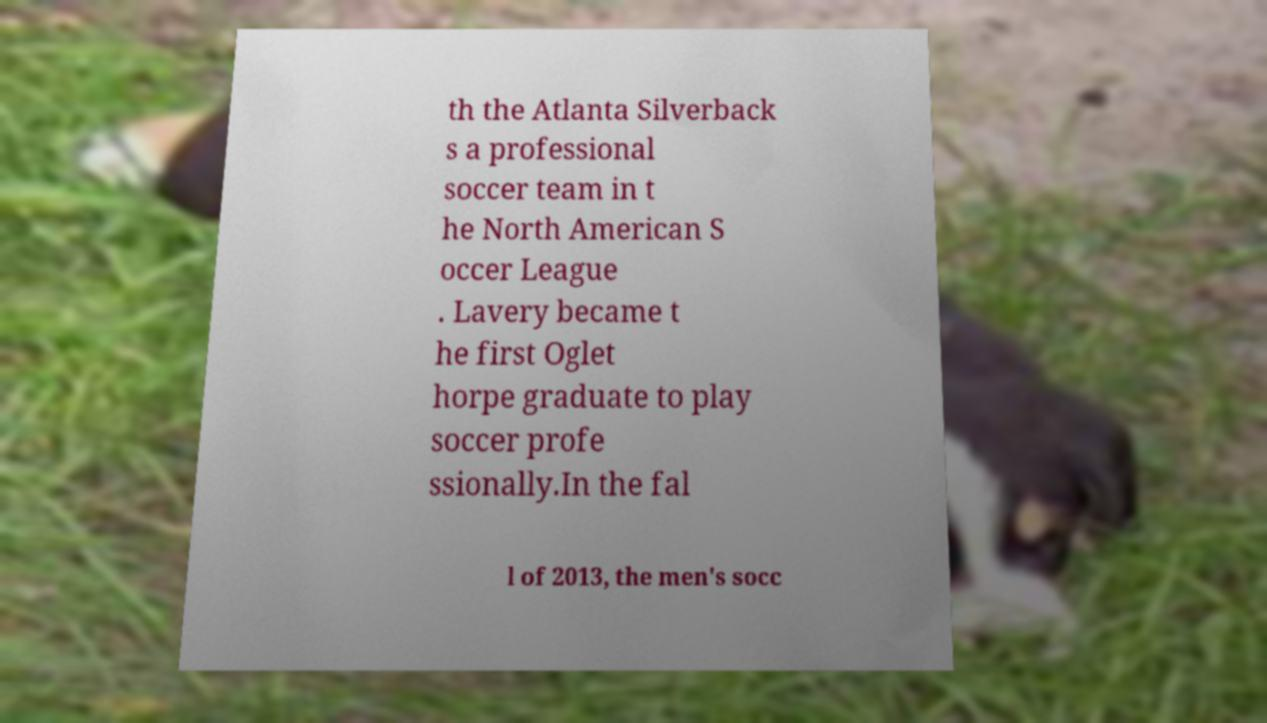Could you extract and type out the text from this image? th the Atlanta Silverback s a professional soccer team in t he North American S occer League . Lavery became t he first Oglet horpe graduate to play soccer profe ssionally.In the fal l of 2013, the men's socc 